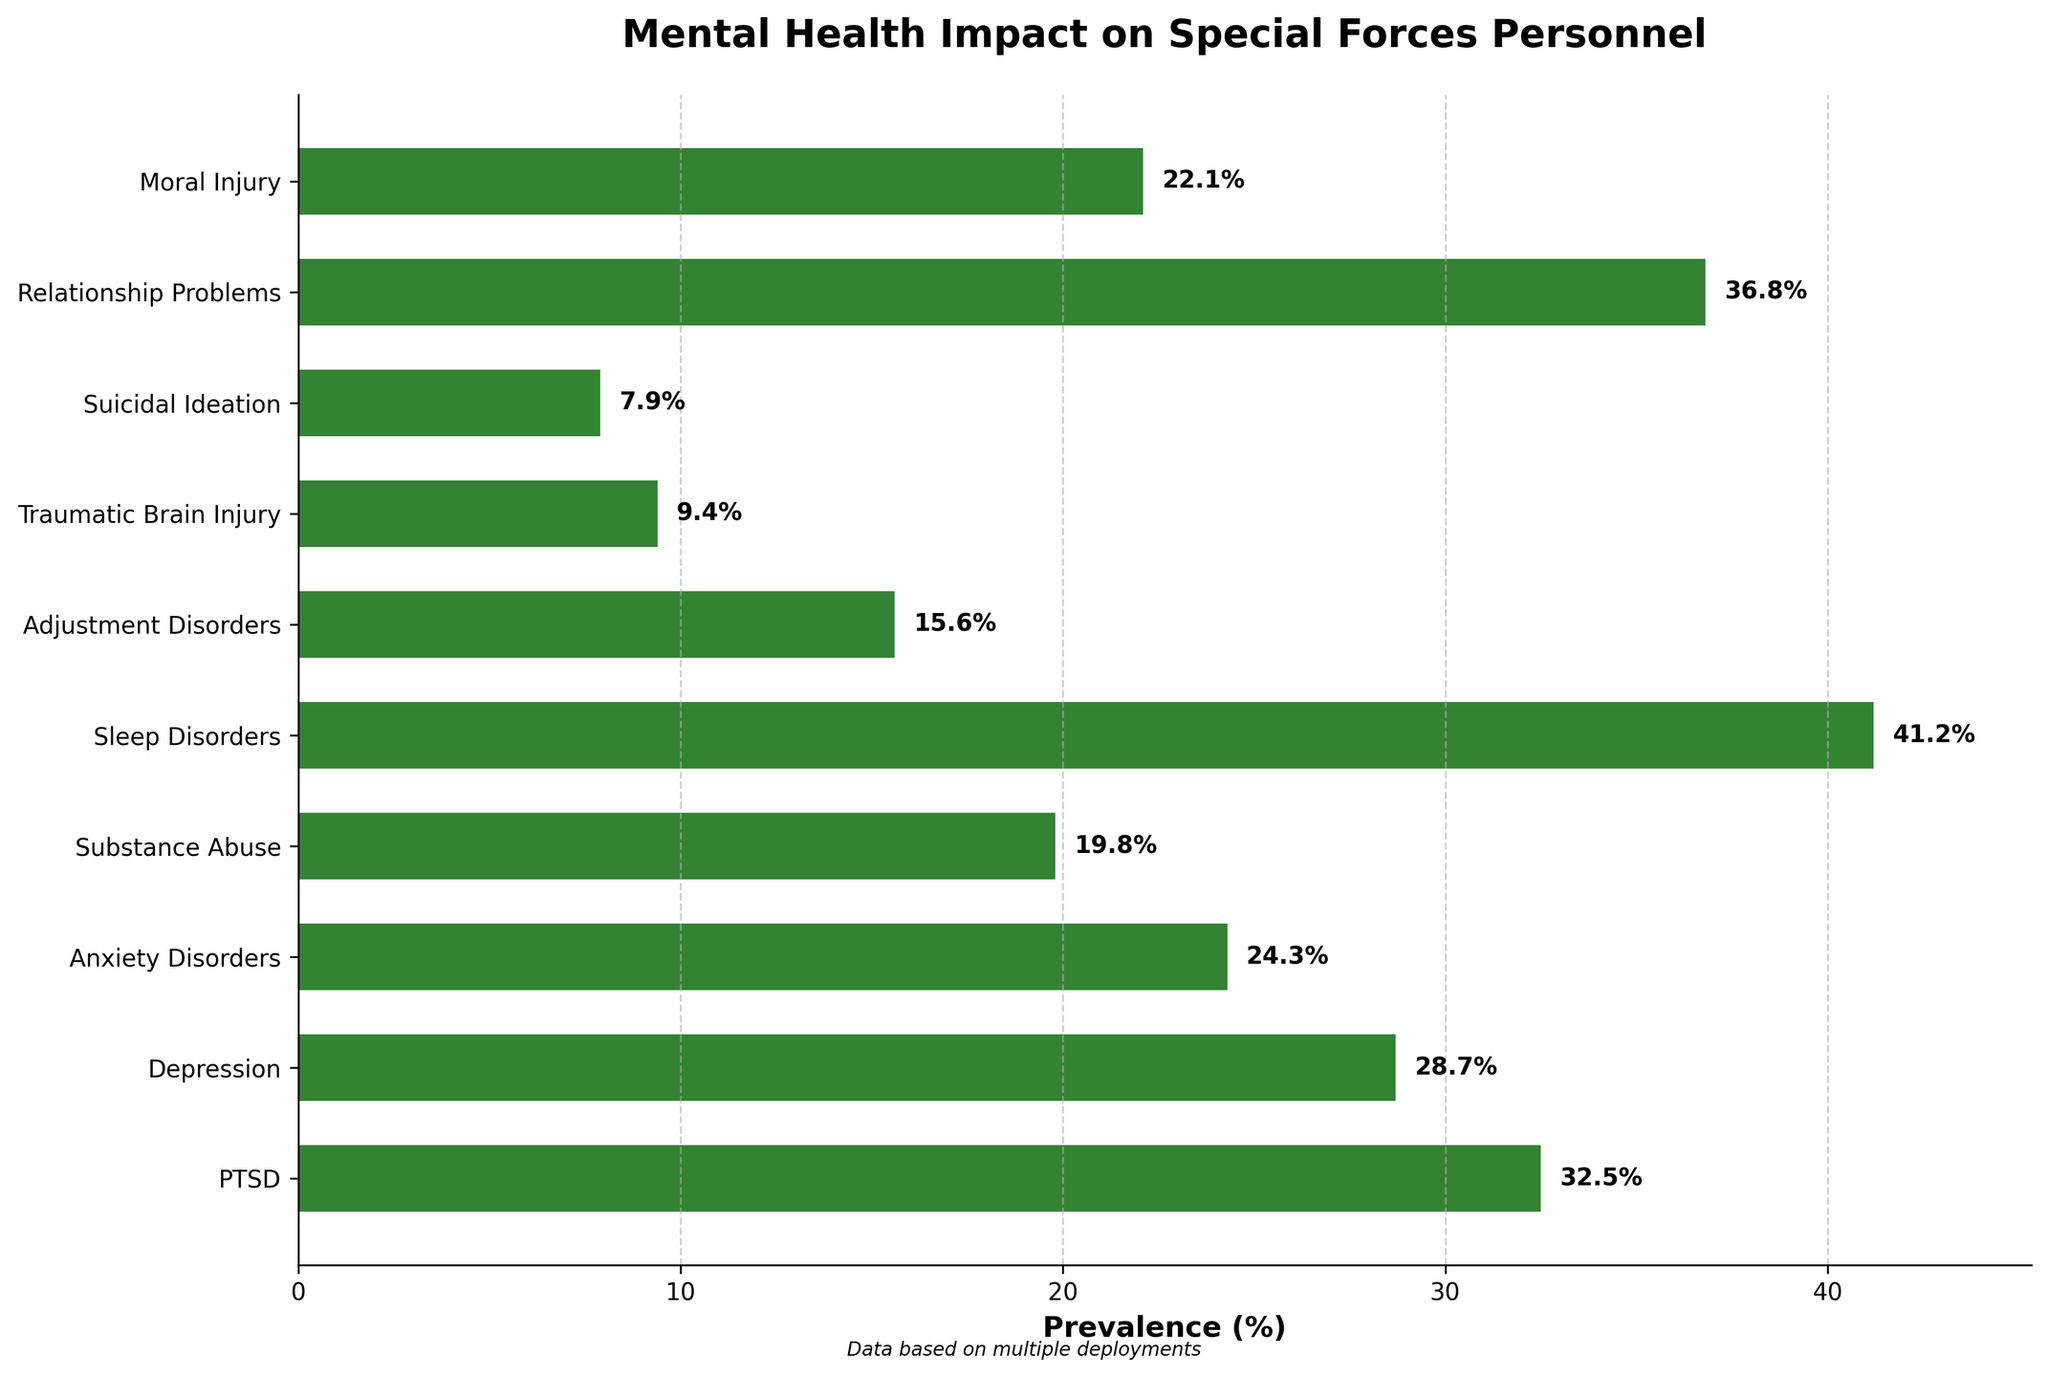What's the most prevalent mental health issue among Special Forces personnel according to the chart? The chart shows horizontal bars representing the prevalence of different mental health issues. The issue with the longest bar is "Sleep Disorders" at 41.2%.
Answer: Sleep Disorders Which mental health issue has a prevalence just above 30%? The chart lists various mental health issues with corresponding percentages. The issue with a prevalence just above 30% is "PTSD" at 32.5%.
Answer: PTSD What is the total prevalence of PTSD and Depression combined? The prevalence of PTSD is 32.5% and Depression is 28.7%. Adding these values gives us 32.5 + 28.7 = 61.2%
Answer: 61.2% Is Anxiety Disorders more prevalent than Traumatic Brain Injury? Comparing the prevalence percentages, Anxiety Disorders is at 24.3%, while Traumatic Brain Injury is at 9.4%. 24.3% is greater than 9.4%.
Answer: Yes Which mental health issue has a lower prevalence, Suicidal Ideation or Adjustment Disorders? The prevalence of Suicidal Ideation is 7.9%, and the prevalence of Adjustment Disorders is 15.6%. Since 7.9% is less than 15.6%, Suicidal Ideation has a lower prevalence.
Answer: Suicidal Ideation How much more prevalent is Relationship Problems compared to Moral Injury? The prevalence of Relationship Problems is 36.8% and Moral Injury is 22.1%. Subtracting these gives 36.8 - 22.1 = 14.7%.
Answer: 14.7% What is the average prevalence of Substance Abuse and Sleep Disorders? The prevalence of Substance Abuse is 19.8% and Sleep Disorders is 41.2%. The average is (19.8 + 41.2) / 2 = 30.5%
Answer: 30.5% Identify the mental health issue with the closest prevalence to 20%. The percentages closest to 20% are Substance Abuse at 19.8% and Moral Injury at 22.1%. Since 19.8% is closer to 20%, the issue is Substance Abuse.
Answer: Substance Abuse Rank the top three most prevalent mental health issues according to the chart. Looking at the bars, the top three are "Sleep Disorders" (41.2%), "Relationship Problems" (36.8%), and "PTSD" (32.5%) in descending order.
Answer: Sleep Disorders, Relationship Problems, PTSD What is the difference in prevalence between the least and most common mental health issues? The least common issue is Suicidal Ideation (7.9%), and the most common is Sleep Disorders (41.2%). The difference is 41.2 - 7.9 = 33.3%.
Answer: 33.3% 